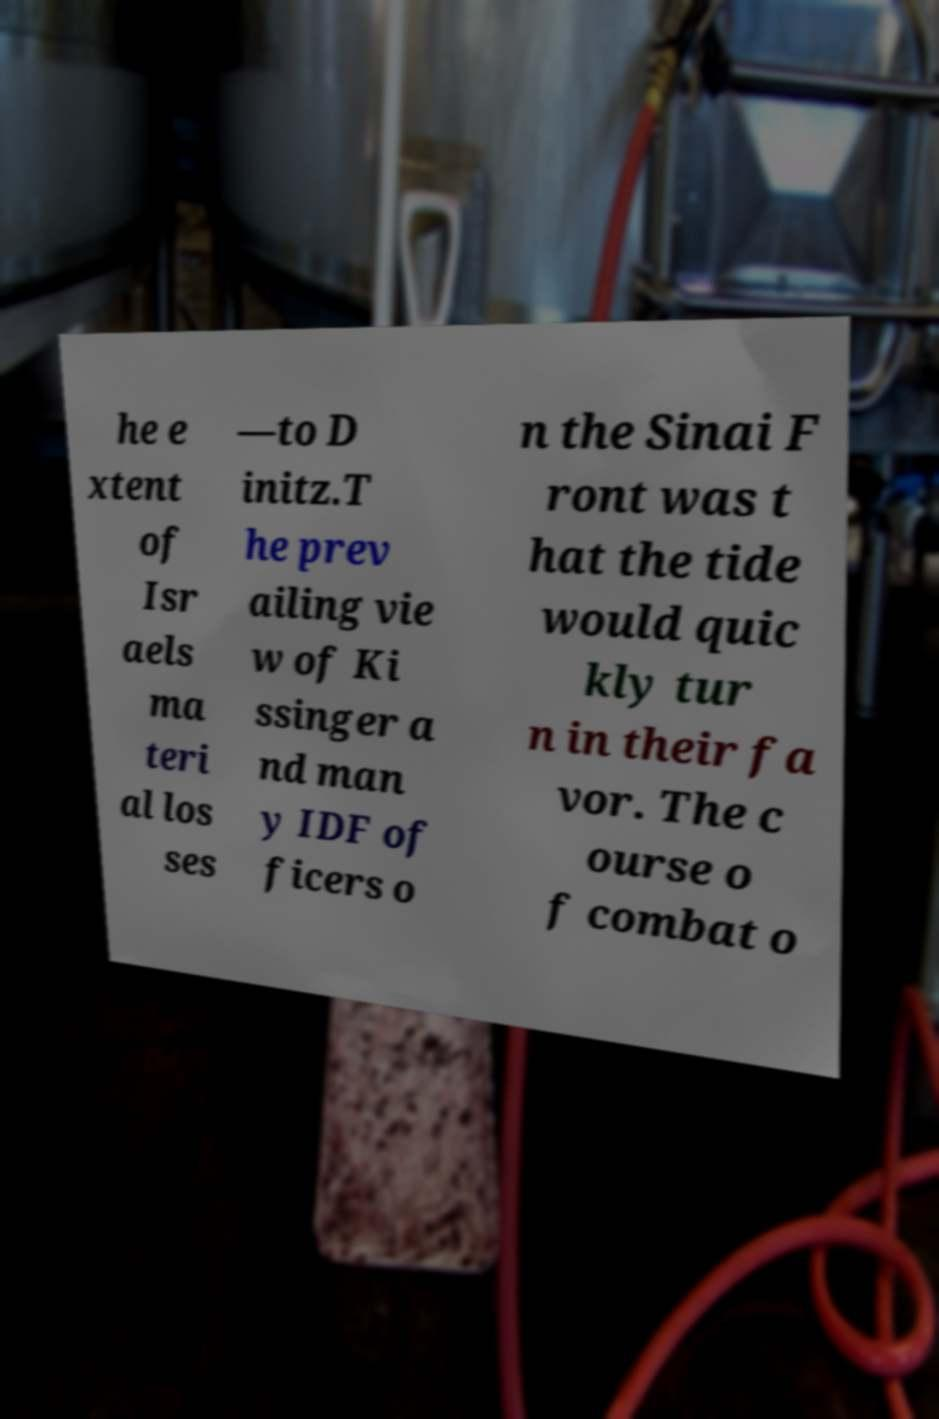Please identify and transcribe the text found in this image. he e xtent of Isr aels ma teri al los ses —to D initz.T he prev ailing vie w of Ki ssinger a nd man y IDF of ficers o n the Sinai F ront was t hat the tide would quic kly tur n in their fa vor. The c ourse o f combat o 